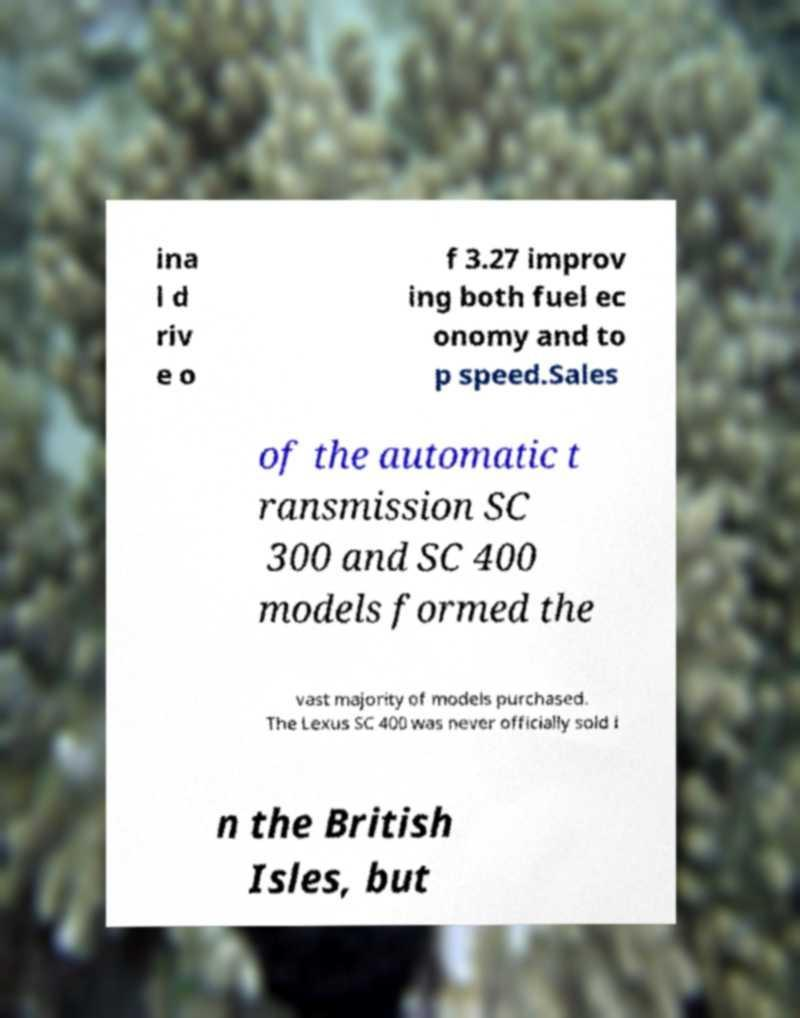I need the written content from this picture converted into text. Can you do that? ina l d riv e o f 3.27 improv ing both fuel ec onomy and to p speed.Sales of the automatic t ransmission SC 300 and SC 400 models formed the vast majority of models purchased. The Lexus SC 400 was never officially sold i n the British Isles, but 